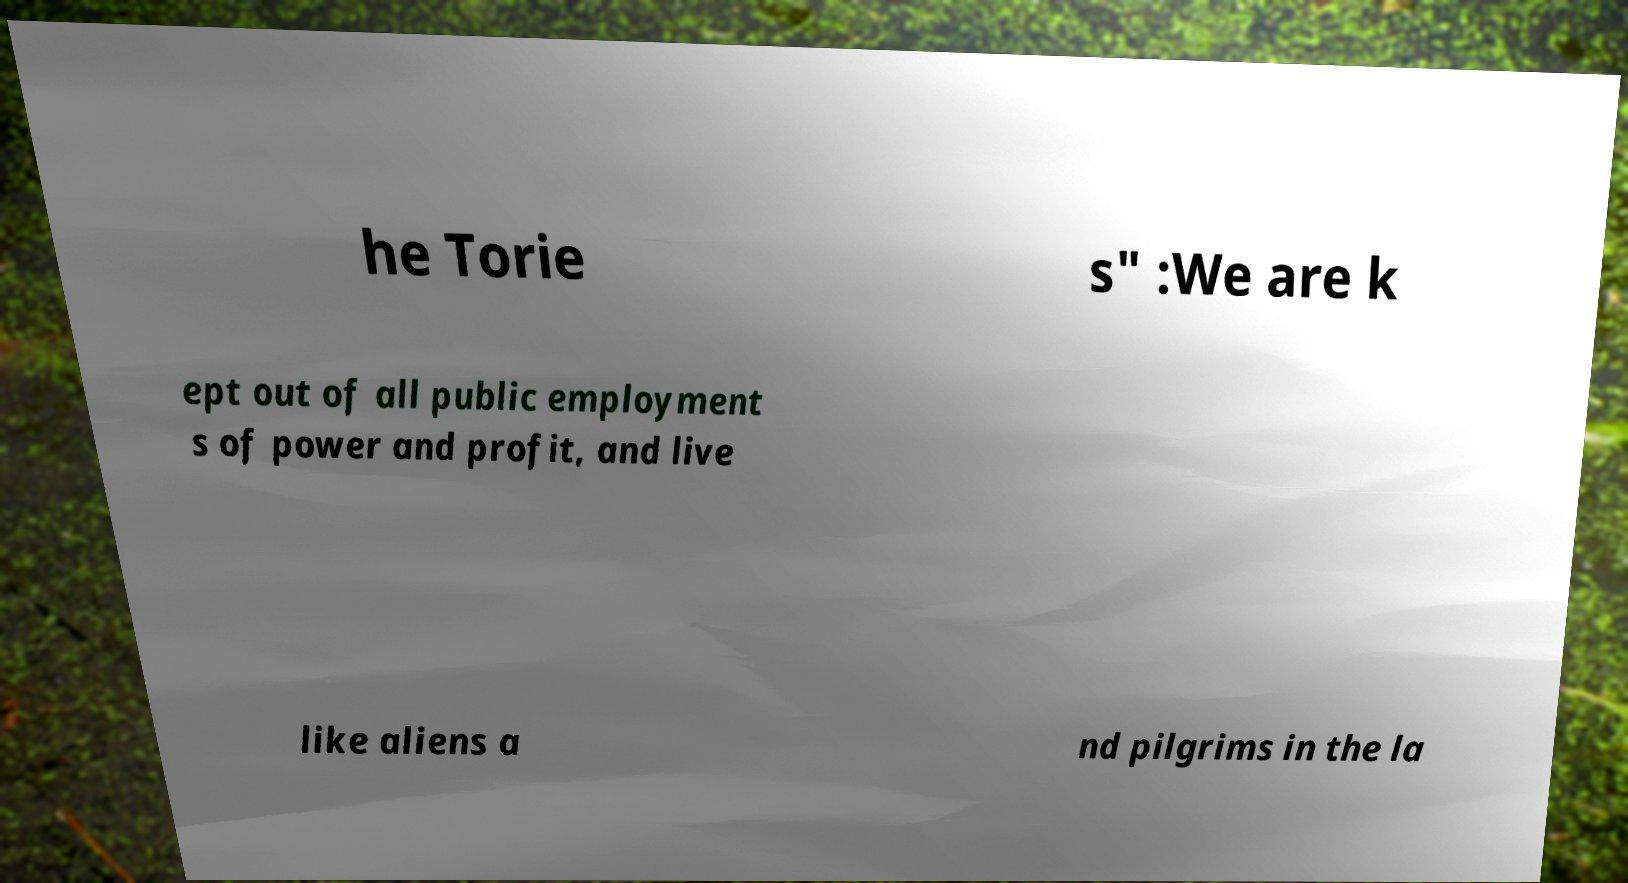Can you accurately transcribe the text from the provided image for me? he Torie s" :We are k ept out of all public employment s of power and profit, and live like aliens a nd pilgrims in the la 